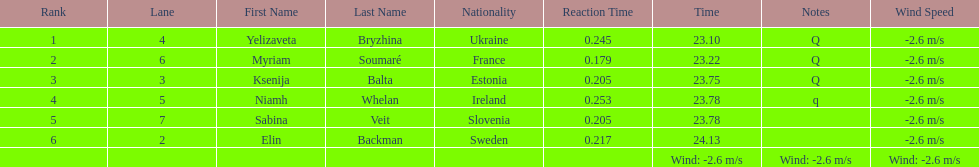Whose time is more than. 24.00? Elin Backman. 